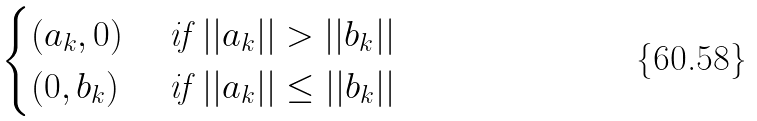Convert formula to latex. <formula><loc_0><loc_0><loc_500><loc_500>\begin{cases} ( a _ { k } , 0 ) & \text { if } | | a _ { k } | | > | | b _ { k } | | \\ ( 0 , b _ { k } ) & \text { if } | | a _ { k } | | \leq | | b _ { k } | | \\ \end{cases}</formula> 